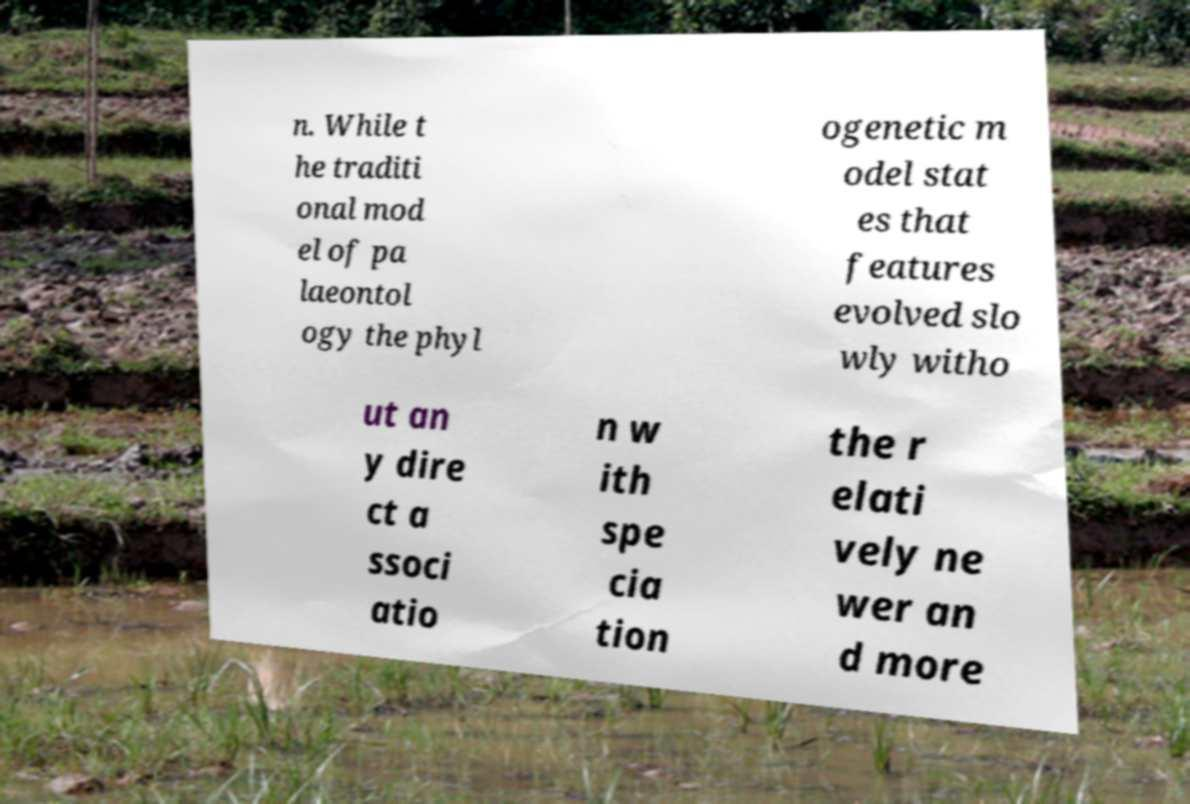What messages or text are displayed in this image? I need them in a readable, typed format. n. While t he traditi onal mod el of pa laeontol ogy the phyl ogenetic m odel stat es that features evolved slo wly witho ut an y dire ct a ssoci atio n w ith spe cia tion the r elati vely ne wer an d more 